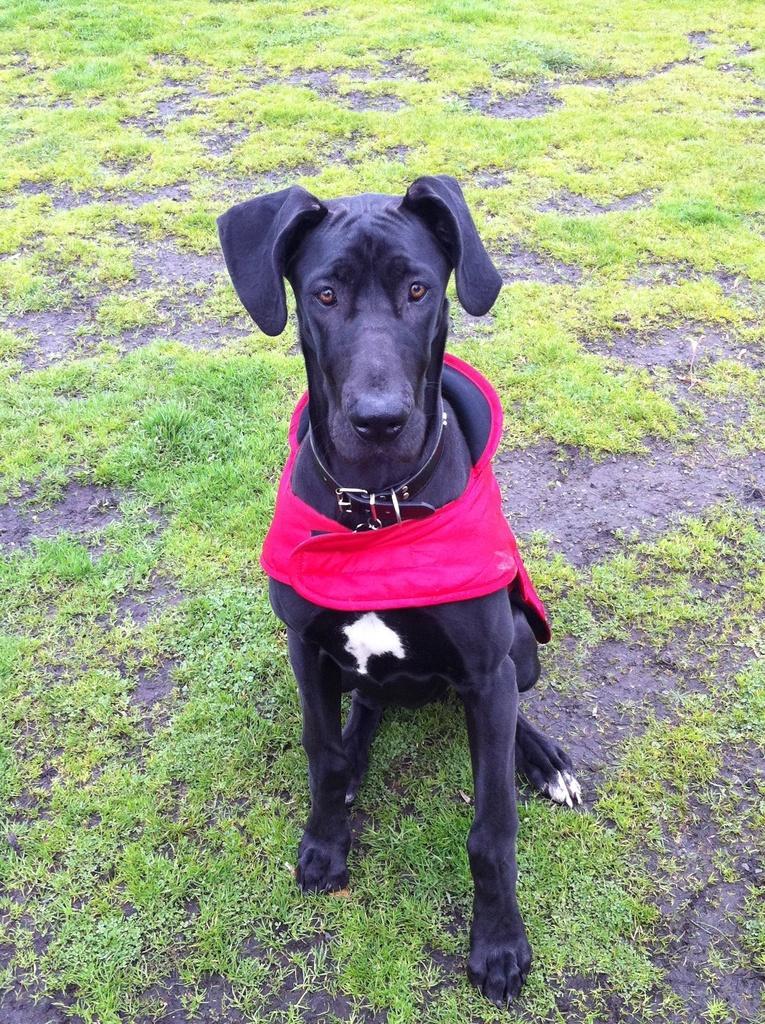Please provide a concise description of this image. In this image a dog is sitting on the land having some grass. Dog is wearing a cloth. 